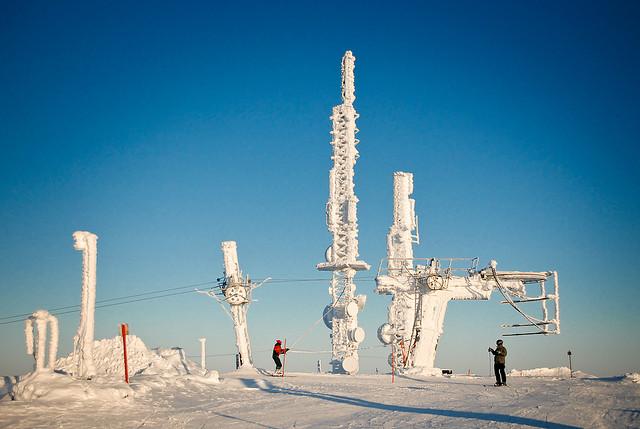Are these statues?
Write a very short answer. No. Does this appear to be a summer day?
Write a very short answer. No. What is all the white stuff?
Keep it brief. Snow. 